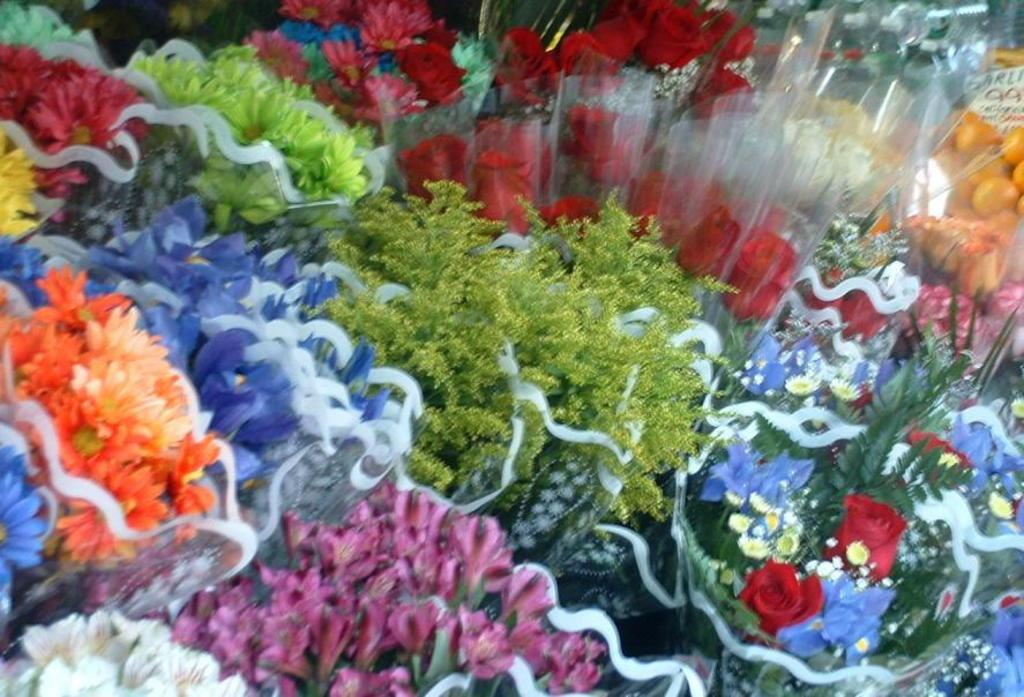Can you describe this image briefly? This picture contains many flower bouquets which are in yellow, blue, pink, green and orange color. 